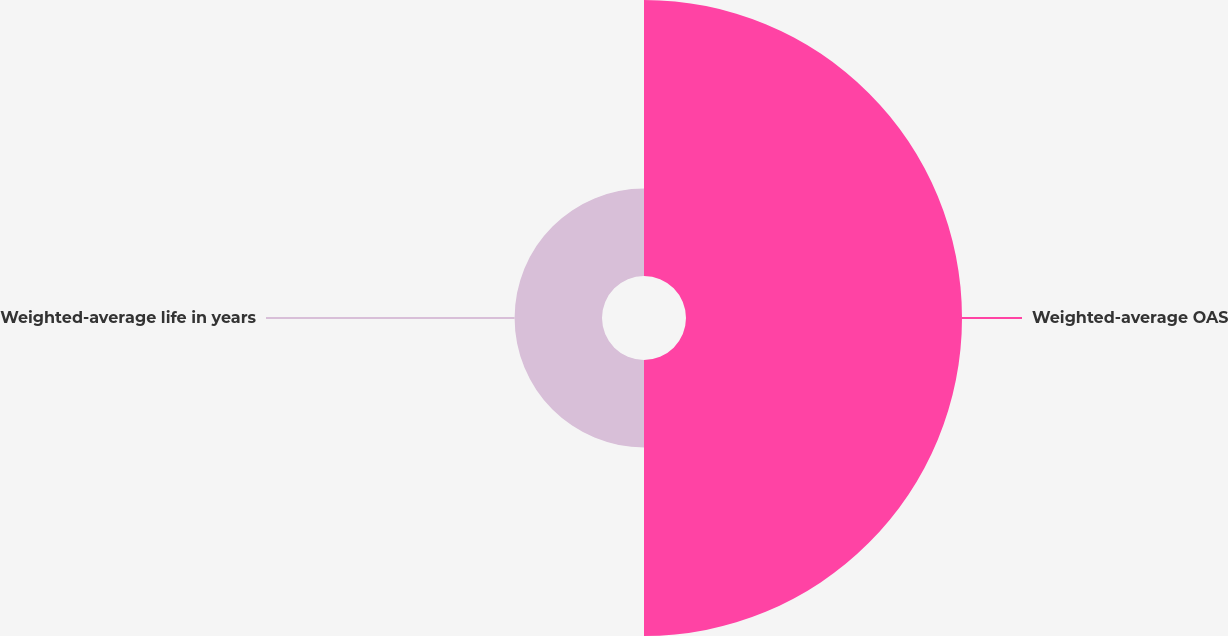<chart> <loc_0><loc_0><loc_500><loc_500><pie_chart><fcel>Weighted-average OAS<fcel>Weighted-average life in years<nl><fcel>75.95%<fcel>24.05%<nl></chart> 